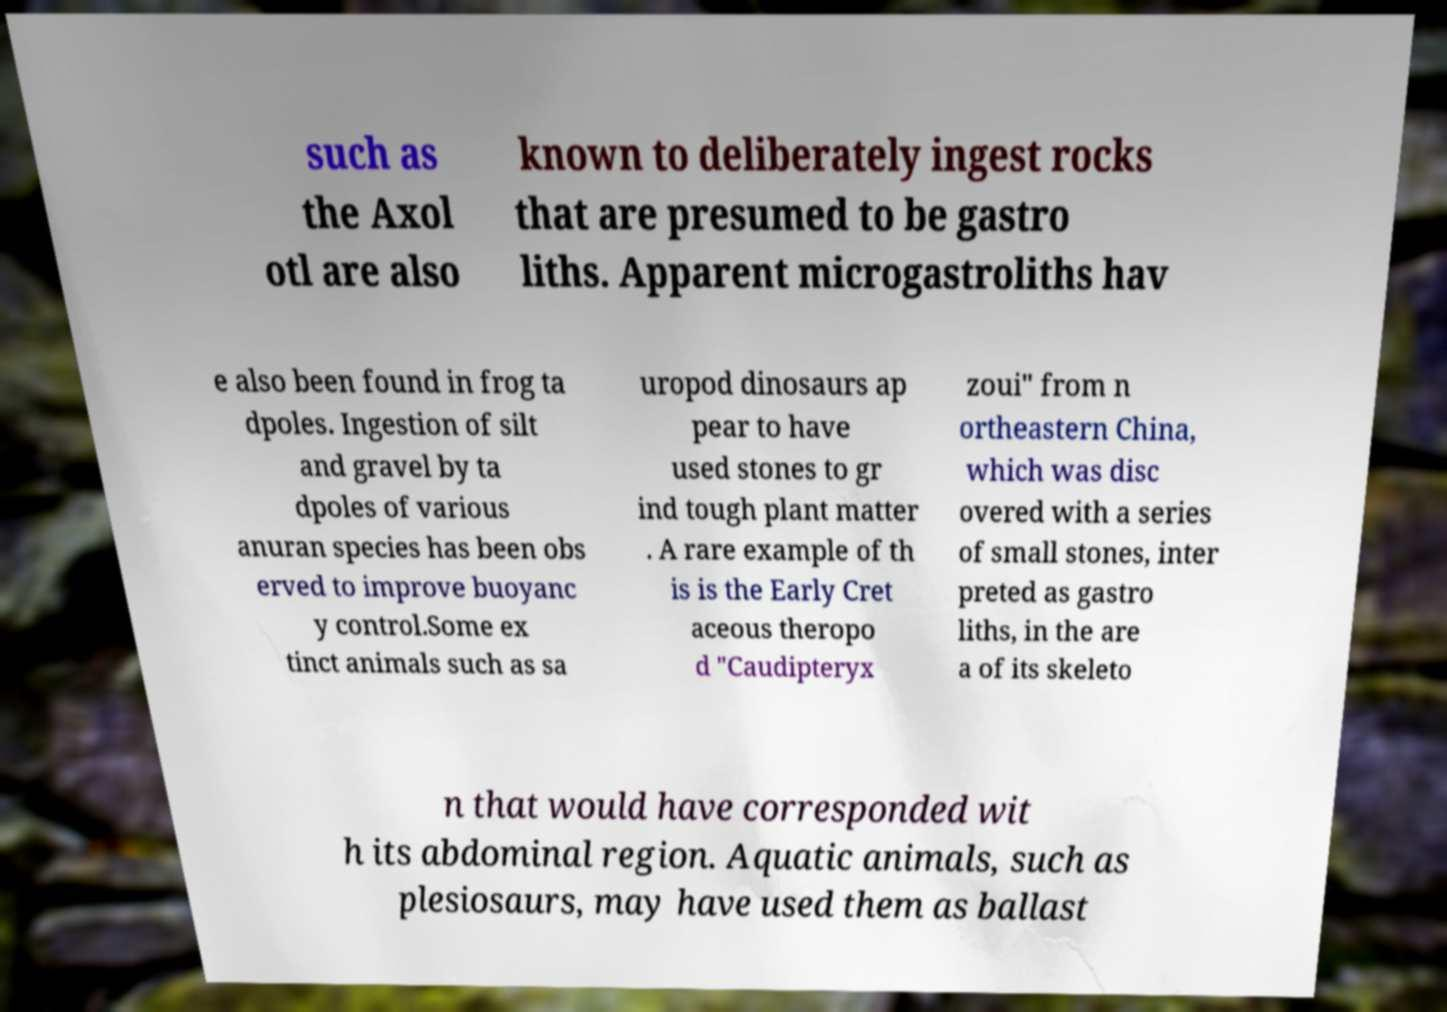Please identify and transcribe the text found in this image. such as the Axol otl are also known to deliberately ingest rocks that are presumed to be gastro liths. Apparent microgastroliths hav e also been found in frog ta dpoles. Ingestion of silt and gravel by ta dpoles of various anuran species has been obs erved to improve buoyanc y control.Some ex tinct animals such as sa uropod dinosaurs ap pear to have used stones to gr ind tough plant matter . A rare example of th is is the Early Cret aceous theropo d "Caudipteryx zoui" from n ortheastern China, which was disc overed with a series of small stones, inter preted as gastro liths, in the are a of its skeleto n that would have corresponded wit h its abdominal region. Aquatic animals, such as plesiosaurs, may have used them as ballast 